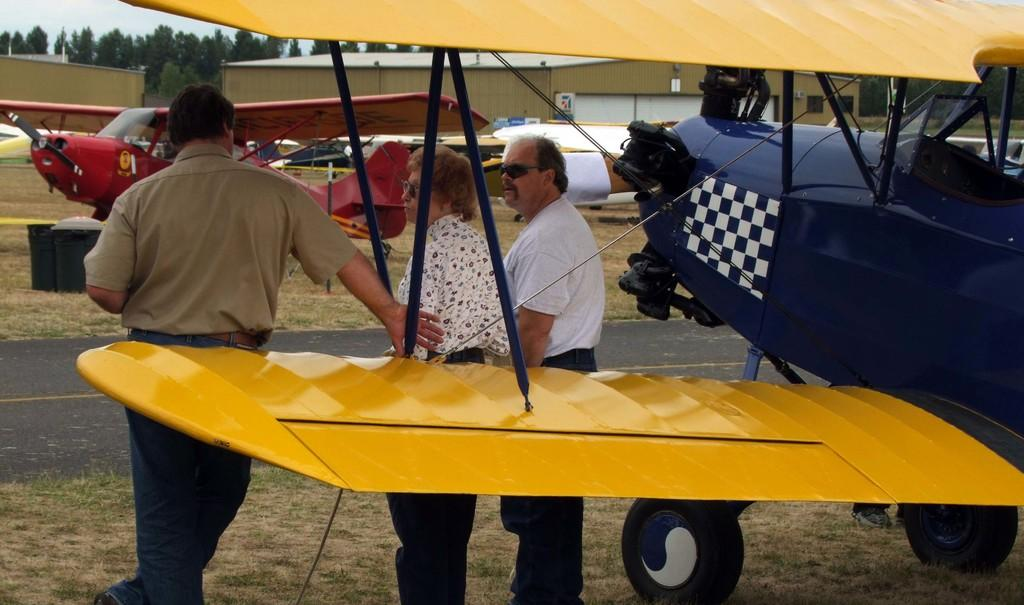What is the main subject of the image? The main subject of the image is a plane. What can be seen on the ground in the image? There are people standing on the ground in the image. What is visible in the background of the image? In the background of the image, there is a road, planes on the ground, sheds, roofs, windows, objects, trees, and the sky. How many boys are playing with the rock and rose in the image? There are no boys, rocks, or roses present in the image. 